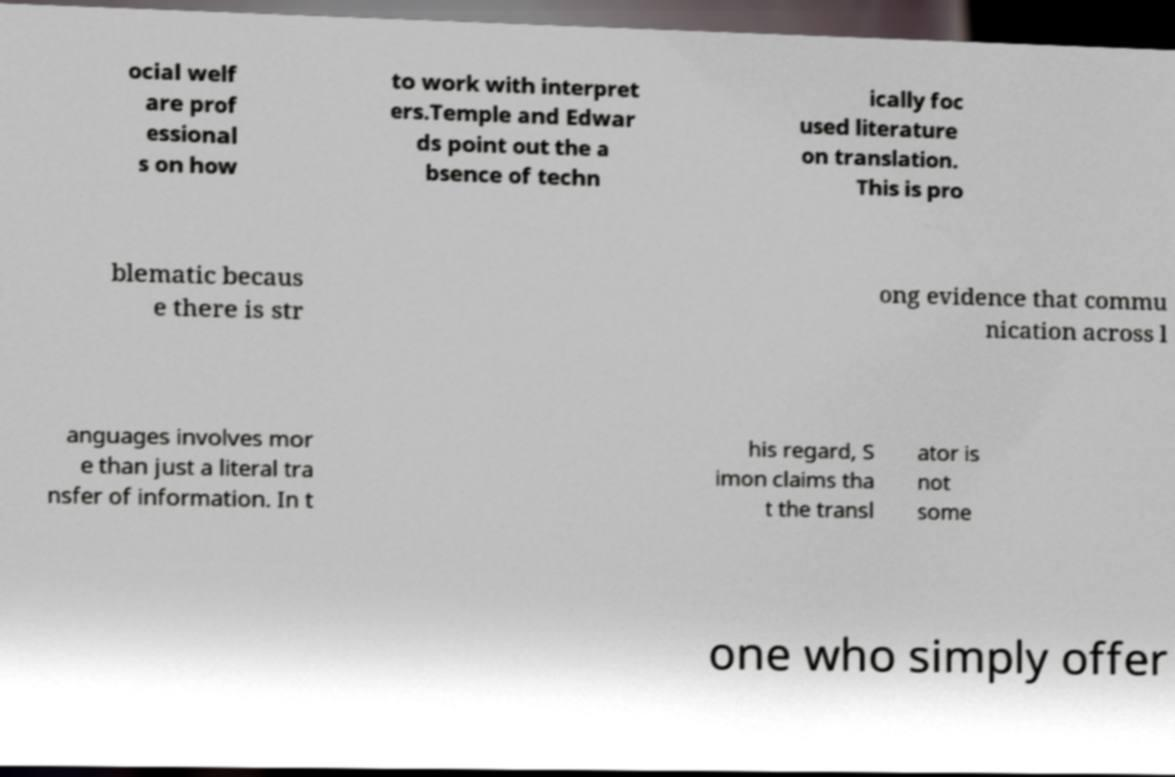For documentation purposes, I need the text within this image transcribed. Could you provide that? ocial welf are prof essional s on how to work with interpret ers.Temple and Edwar ds point out the a bsence of techn ically foc used literature on translation. This is pro blematic becaus e there is str ong evidence that commu nication across l anguages involves mor e than just a literal tra nsfer of information. In t his regard, S imon claims tha t the transl ator is not some one who simply offer 